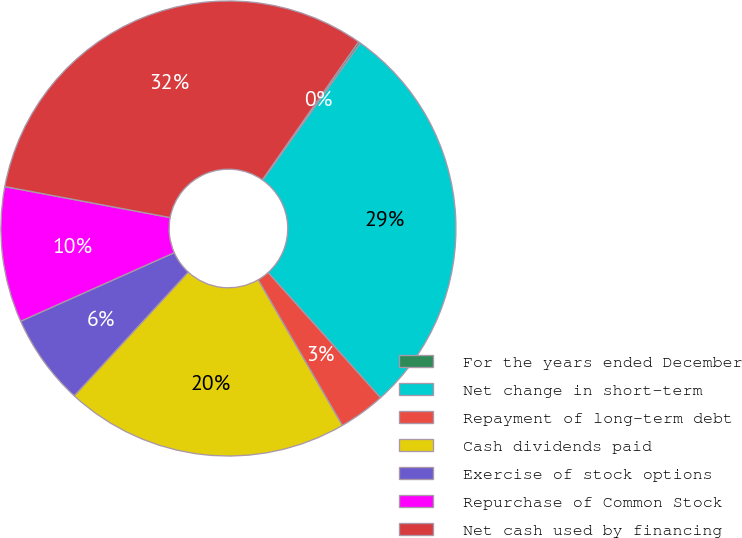<chart> <loc_0><loc_0><loc_500><loc_500><pie_chart><fcel>For the years ended December<fcel>Net change in short-term<fcel>Repayment of long-term debt<fcel>Cash dividends paid<fcel>Exercise of stock options<fcel>Repurchase of Common Stock<fcel>Net cash used by financing<nl><fcel>0.15%<fcel>28.51%<fcel>3.31%<fcel>20.19%<fcel>6.47%<fcel>9.63%<fcel>31.74%<nl></chart> 